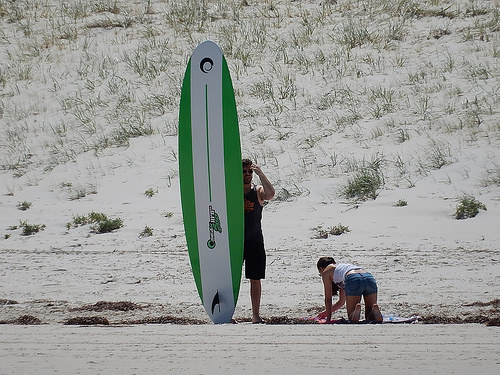<image>
Is there a women to the left of the man? Yes. From this viewpoint, the women is positioned to the left side relative to the man. Is there a man next to the lady? Yes. The man is positioned adjacent to the lady, located nearby in the same general area. 